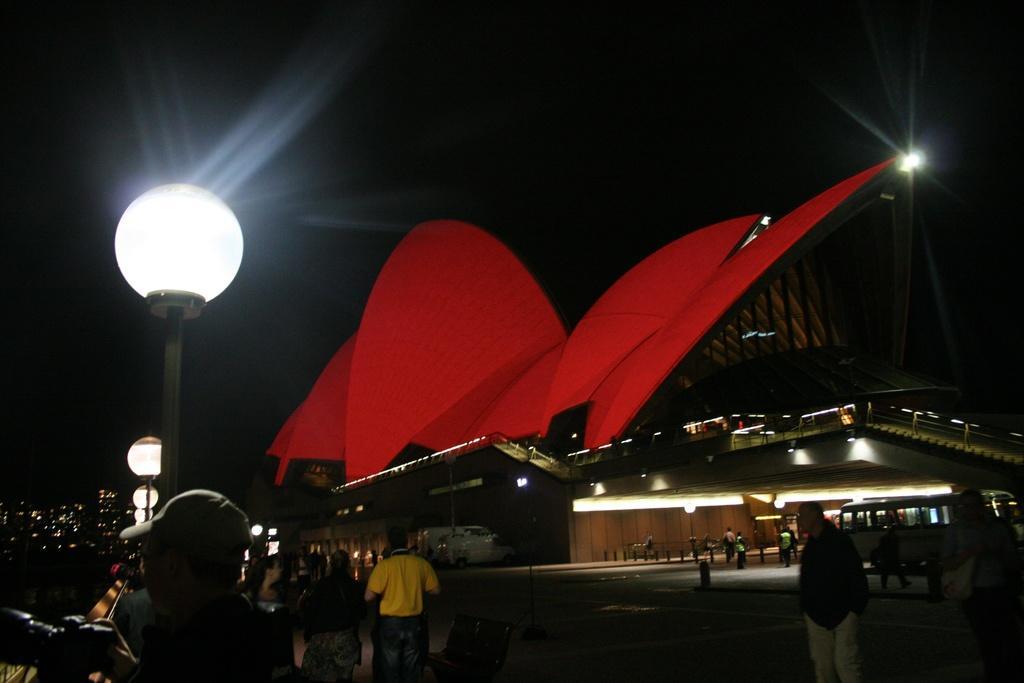Could you give a brief overview of what you see in this image? In the foreground I can see a crowd on the road, light poles, fence, vehicles, buildings and rooftop. In the background I can see the sky. This image is taken may be during night. 